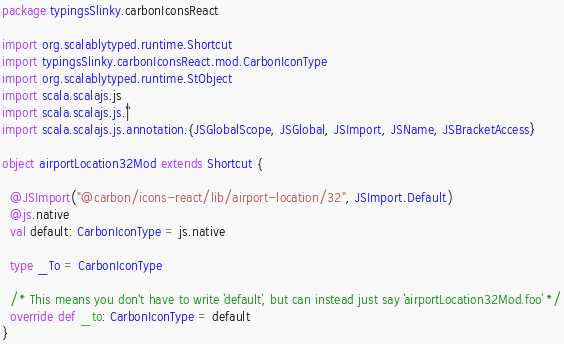<code> <loc_0><loc_0><loc_500><loc_500><_Scala_>package typingsSlinky.carbonIconsReact

import org.scalablytyped.runtime.Shortcut
import typingsSlinky.carbonIconsReact.mod.CarbonIconType
import org.scalablytyped.runtime.StObject
import scala.scalajs.js
import scala.scalajs.js.`|`
import scala.scalajs.js.annotation.{JSGlobalScope, JSGlobal, JSImport, JSName, JSBracketAccess}

object airportLocation32Mod extends Shortcut {
  
  @JSImport("@carbon/icons-react/lib/airport-location/32", JSImport.Default)
  @js.native
  val default: CarbonIconType = js.native
  
  type _To = CarbonIconType
  
  /* This means you don't have to write `default`, but can instead just say `airportLocation32Mod.foo` */
  override def _to: CarbonIconType = default
}
</code> 